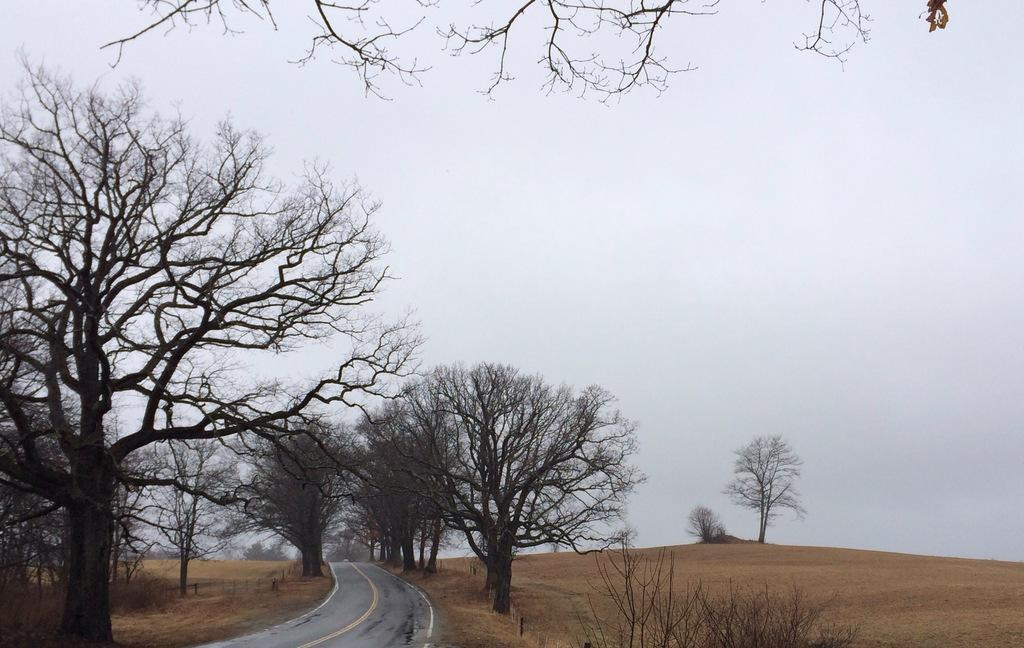What type of natural elements can be seen in the image? There are trees and plants in the image. What man-made structure is visible in the image? There is a road in the image. What part of the natural environment is visible in the background of the image? The sky is visible in the background of the image. What type of calculator is being used by the minister in the image? There is no calculator or minister present in the image. 